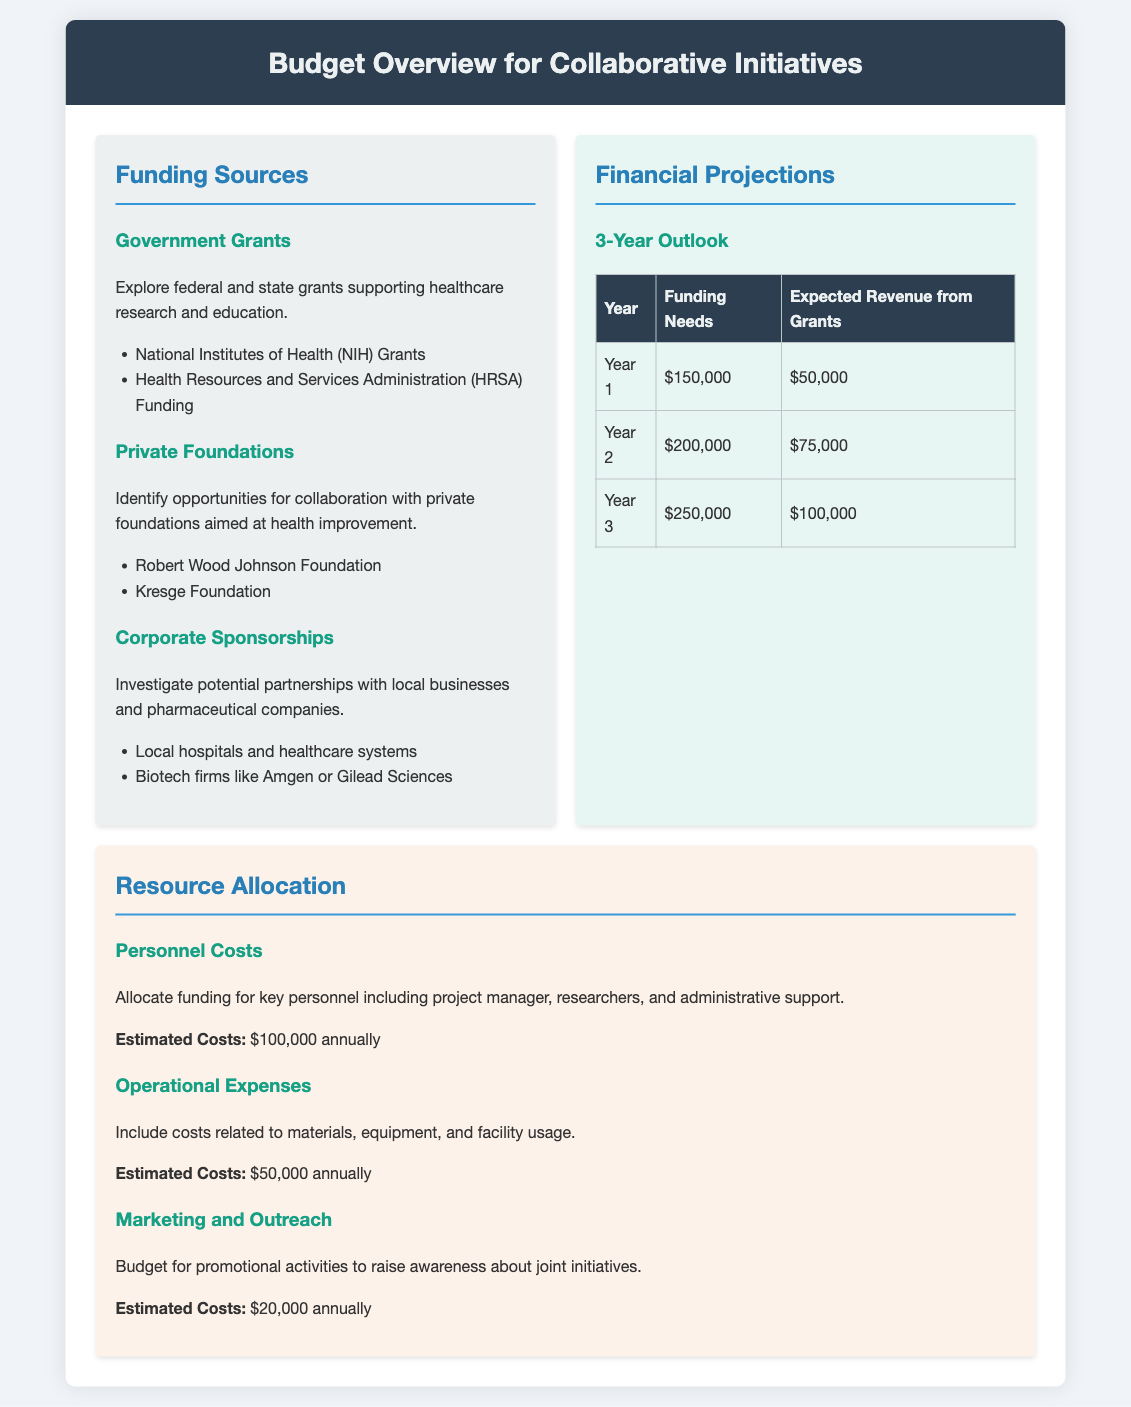What are the two main sources of funding listed in the document? The document provides specific categories of funding sources. The examples include government grants, private foundations, and corporate sponsorships.
Answer: Government Grants, Private Foundations What is the total funding need for Year 2? The document specifies the funding needs for each year. Year 2's funding need is directly stated.
Answer: $200,000 What is the expected revenue from grants in Year 3? The document outlines the expected revenue from grants on a yearly basis. Year 3's expected revenue is provided explicitly.
Answer: $100,000 What is the estimated annual cost for personnel? The document mentions the estimated costs for personnel as part of resource allocation.
Answer: $100,000 annually Which foundation is specifically named in the private foundations section? The document lists specific private foundations under the funding sources section.
Answer: Robert Wood Johnson Foundation What is the budget allocated for marketing and outreach annually? The document provides information about marketing and outreach costs in terms of annual budget allocation.
Answer: $20,000 annually What is the total funding need over the three years? The document specifies the funding needs for each of the three years, which can be added together.
Answer: $600,000 What is the background color of the financial projections section? The document describes a specific background color for the financial projections section, indicating a visual aspect.
Answer: Light blue 